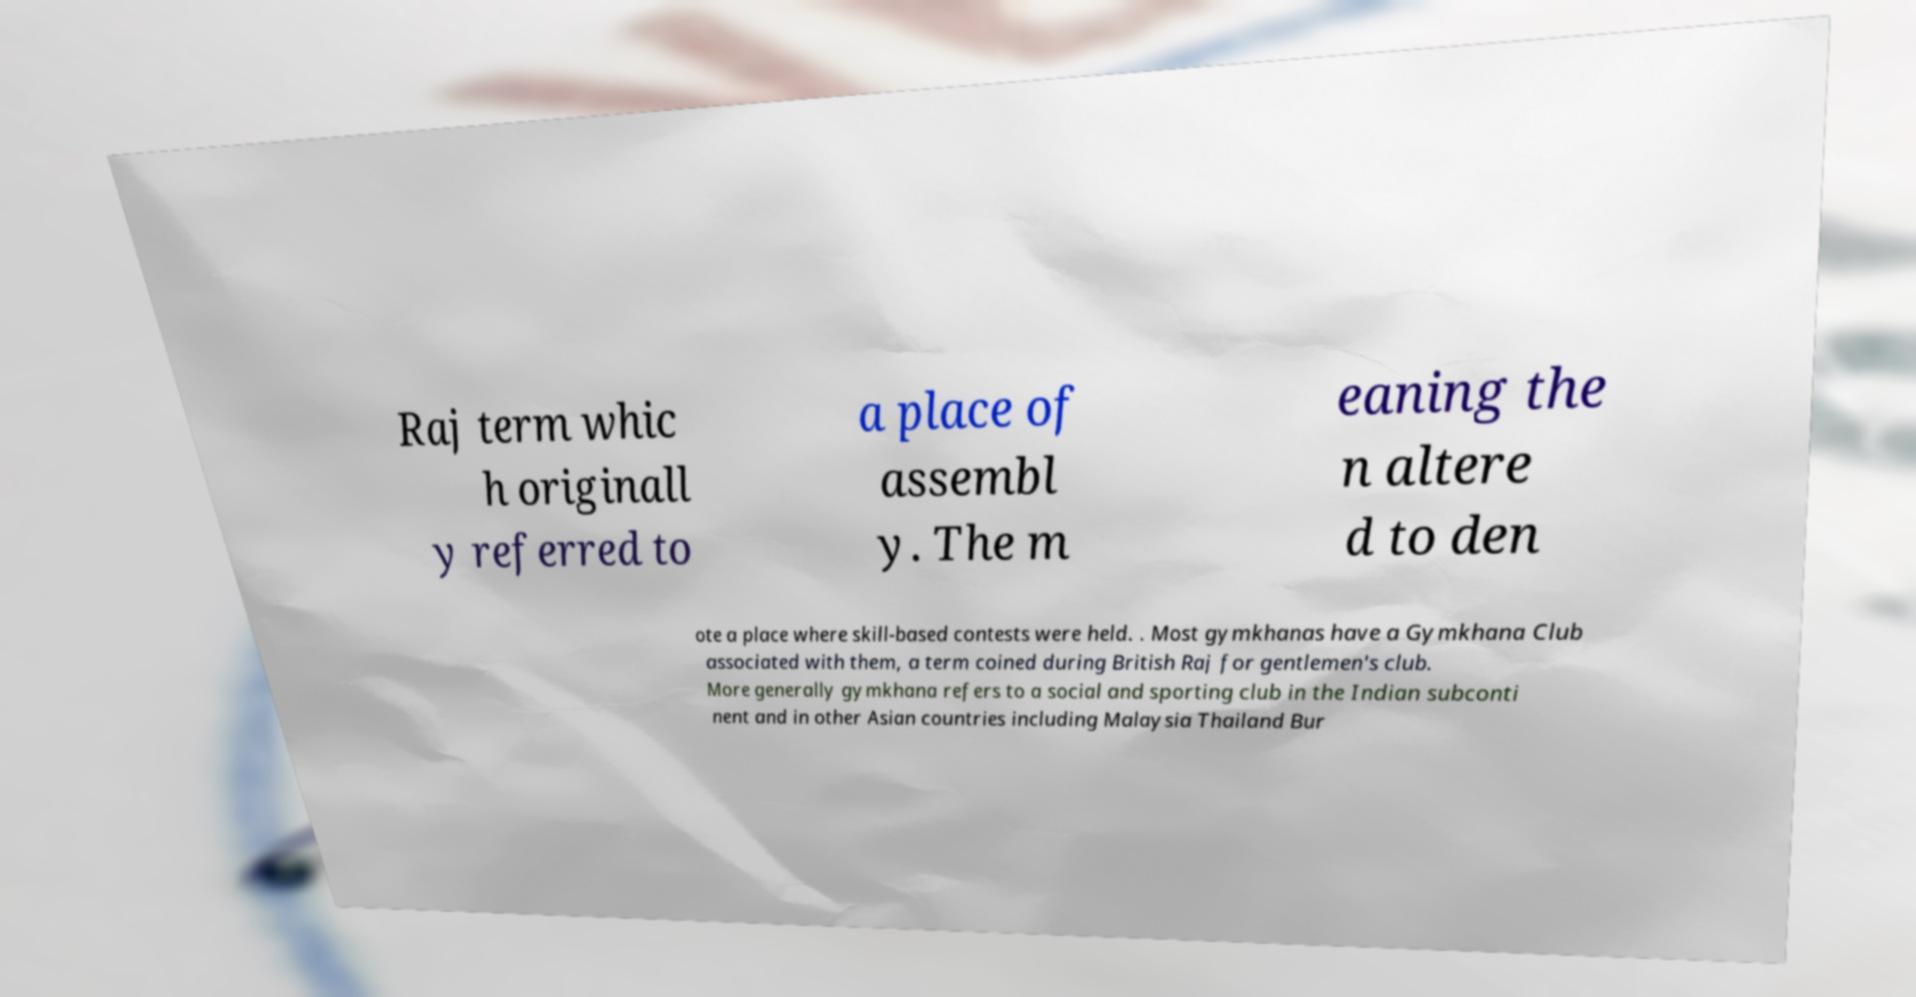Can you read and provide the text displayed in the image?This photo seems to have some interesting text. Can you extract and type it out for me? Raj term whic h originall y referred to a place of assembl y. The m eaning the n altere d to den ote a place where skill-based contests were held. . Most gymkhanas have a Gymkhana Club associated with them, a term coined during British Raj for gentlemen's club. More generally gymkhana refers to a social and sporting club in the Indian subconti nent and in other Asian countries including Malaysia Thailand Bur 